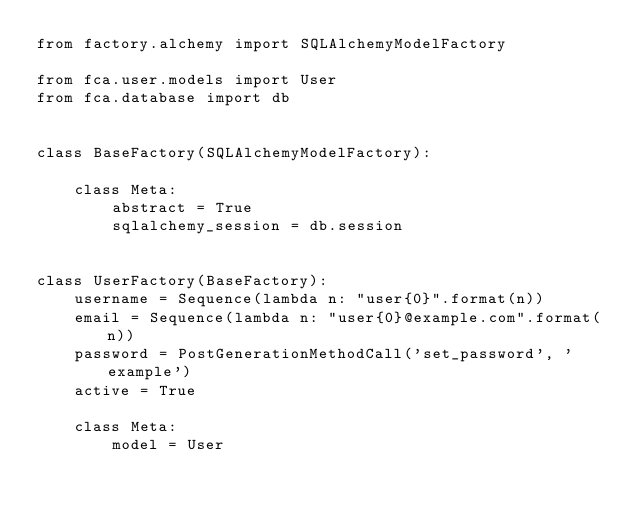Convert code to text. <code><loc_0><loc_0><loc_500><loc_500><_Python_>from factory.alchemy import SQLAlchemyModelFactory

from fca.user.models import User
from fca.database import db


class BaseFactory(SQLAlchemyModelFactory):

    class Meta:
        abstract = True
        sqlalchemy_session = db.session


class UserFactory(BaseFactory):
    username = Sequence(lambda n: "user{0}".format(n))
    email = Sequence(lambda n: "user{0}@example.com".format(n))
    password = PostGenerationMethodCall('set_password', 'example')
    active = True

    class Meta:
        model = User
</code> 